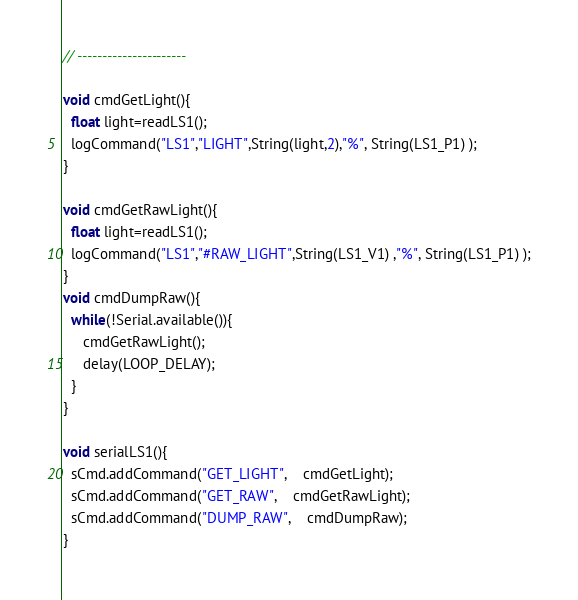Convert code to text. <code><loc_0><loc_0><loc_500><loc_500><_C_>// ----------------------

void cmdGetLight(){
  float light=readLS1();
  logCommand("LS1","LIGHT",String(light,2),"%", String(LS1_P1) );
}

void cmdGetRawLight(){
  float light=readLS1();
  logCommand("LS1","#RAW_LIGHT",String(LS1_V1) ,"%", String(LS1_P1) );
}
void cmdDumpRaw(){
  while(!Serial.available()){
     cmdGetRawLight(); 
     delay(LOOP_DELAY);
  }
}

void serialLS1(){
  sCmd.addCommand("GET_LIGHT",    cmdGetLight);  
  sCmd.addCommand("GET_RAW",    cmdGetRawLight);    
  sCmd.addCommand("DUMP_RAW",    cmdDumpRaw);       
}
</code> 